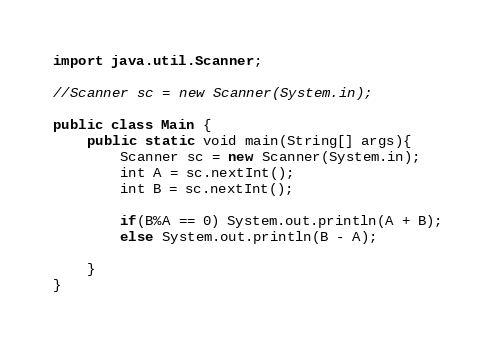<code> <loc_0><loc_0><loc_500><loc_500><_Java_>import java.util.Scanner;

//Scanner sc = new Scanner(System.in);

public class Main {
	public static void main(String[] args){
		Scanner sc = new Scanner(System.in);
		int A = sc.nextInt();
		int B = sc.nextInt();
		
		if(B%A == 0) System.out.println(A + B);
		else System.out.println(B - A);
		
	}
}
</code> 